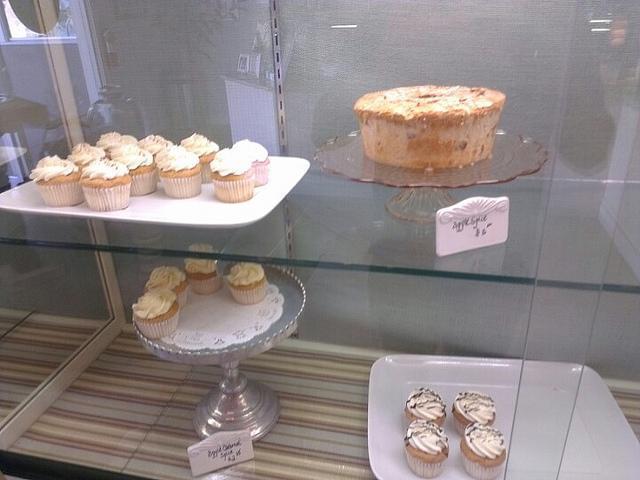How many racks of donuts are there?
Give a very brief answer. 0. How many cakes are pink?
Give a very brief answer. 1. How many cakes are in the photo?
Give a very brief answer. 5. 